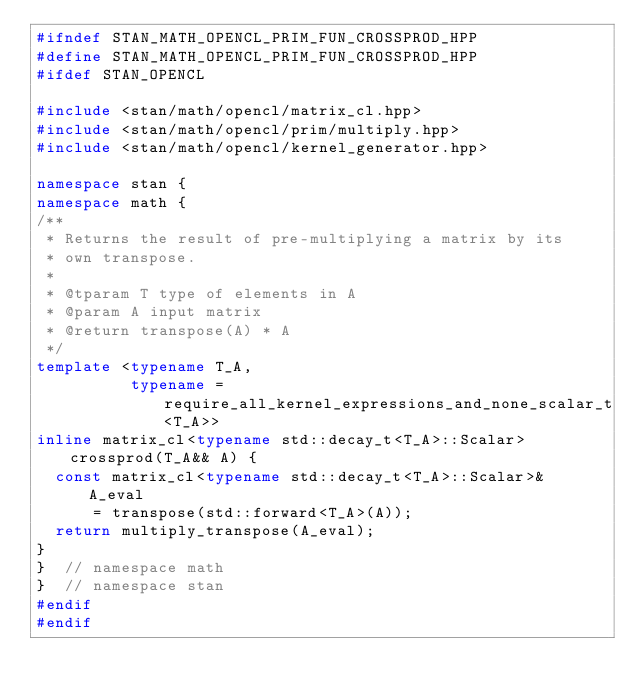<code> <loc_0><loc_0><loc_500><loc_500><_C++_>#ifndef STAN_MATH_OPENCL_PRIM_FUN_CROSSPROD_HPP
#define STAN_MATH_OPENCL_PRIM_FUN_CROSSPROD_HPP
#ifdef STAN_OPENCL

#include <stan/math/opencl/matrix_cl.hpp>
#include <stan/math/opencl/prim/multiply.hpp>
#include <stan/math/opencl/kernel_generator.hpp>

namespace stan {
namespace math {
/**
 * Returns the result of pre-multiplying a matrix by its
 * own transpose.
 *
 * @tparam T type of elements in A
 * @param A input matrix
 * @return transpose(A) * A
 */
template <typename T_A,
          typename = require_all_kernel_expressions_and_none_scalar_t<T_A>>
inline matrix_cl<typename std::decay_t<T_A>::Scalar> crossprod(T_A&& A) {
  const matrix_cl<typename std::decay_t<T_A>::Scalar>& A_eval
      = transpose(std::forward<T_A>(A));
  return multiply_transpose(A_eval);
}
}  // namespace math
}  // namespace stan
#endif
#endif
</code> 